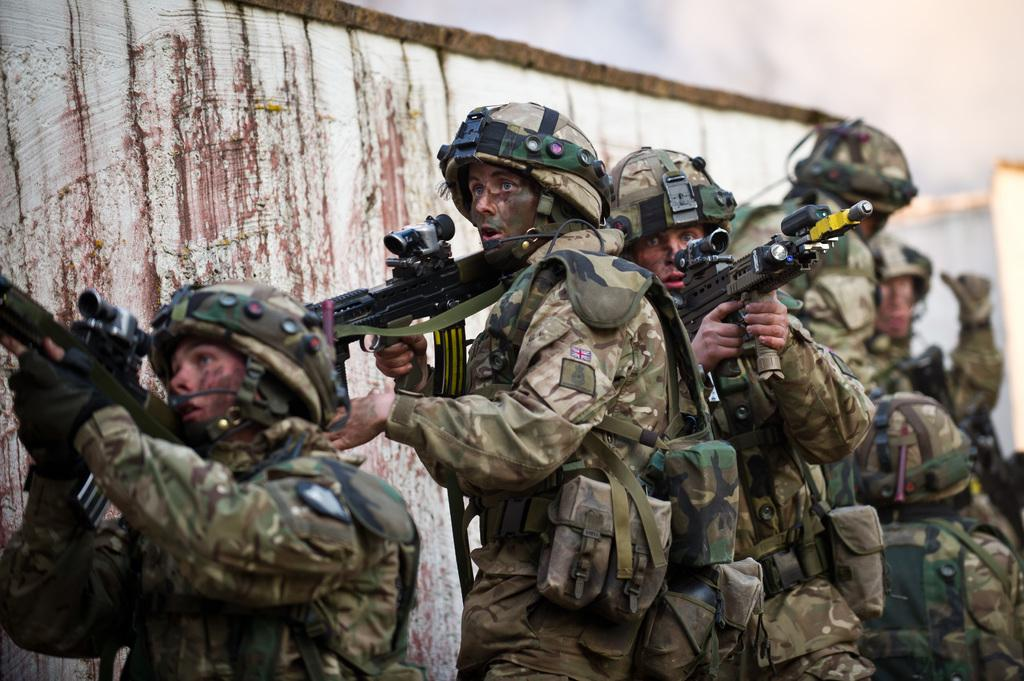What type of people can be seen in the image? There are army people in the image. Where are the army people located in the image? The army people are standing beside a wall. What are the army people holding in the image? The army people are holding guns. What type of net can be seen in the image? There is no net present in the image. What crime are the army people investigating in the image? The image does not depict any crime or investigation; it simply shows army people standing beside a wall and holding guns. 